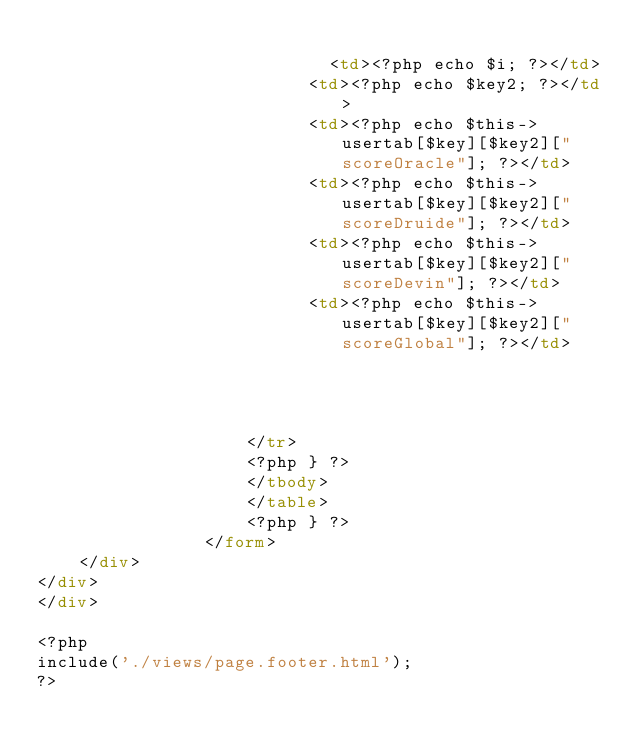Convert code to text. <code><loc_0><loc_0><loc_500><loc_500><_HTML_>					      
							<td><?php echo $i; ?></td>
						  <td><?php echo $key2; ?></td>
						  <td><?php echo $this->usertab[$key][$key2]["scoreOracle"]; ?></td>
						  <td><?php echo $this->usertab[$key][$key2]["scoreDruide"]; ?></td>
						  <td><?php echo $this->usertab[$key][$key2]["scoreDevin"]; ?></td>
						  <td><?php echo $this->usertab[$key][$key2]["scoreGlobal"]; ?></td>
						
					      
					    
					
					</tr>
					<?php } ?>
					</tbody>
					</table> 
					<?php } ?> 
				</form>
	</div>
</div>
</div>

<?php
include('./views/page.footer.html');
?>
</code> 